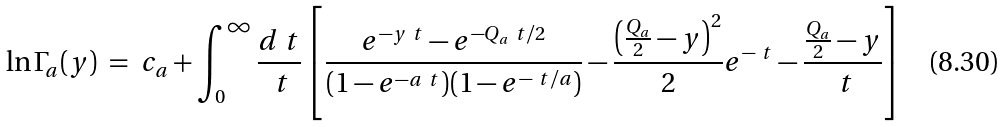<formula> <loc_0><loc_0><loc_500><loc_500>\ln \Gamma _ { a } ( y ) \ = \ c _ { a } + \int _ { 0 } ^ { \infty } \frac { d \ t } { \ t } \left [ \frac { e ^ { - y \ t } - e ^ { - Q _ { a } \ t / 2 } } { ( 1 - e ^ { - a \ t } ) ( 1 - e ^ { - \ t / a } ) } - \frac { \left ( \frac { Q _ { a } } { 2 } - y \right ) ^ { 2 } } { 2 } e ^ { - \ t } - \frac { \frac { Q _ { a } } { 2 } - y } { \ t } \right ]</formula> 